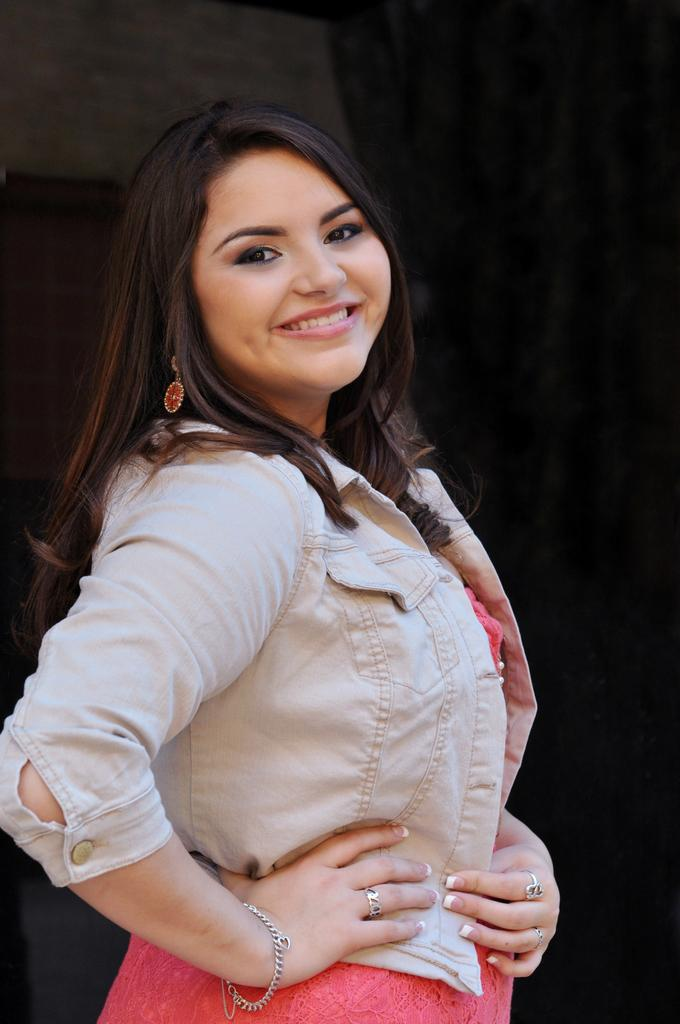What is the main subject of the image? The main subject of the image is a woman. What is the woman doing in the image? The woman is standing in the image. What is the woman's facial expression in the image? The woman is smiling in the image. What type of town can be seen in the background of the image? There is no town visible in the background of the image. What is the woman doing at the edge of the image? The woman is not depicted at the edge of the image; she is standing in the center. What type of sport is the woman playing in the image? There is no sport, such as volleyball, being played in the image. 